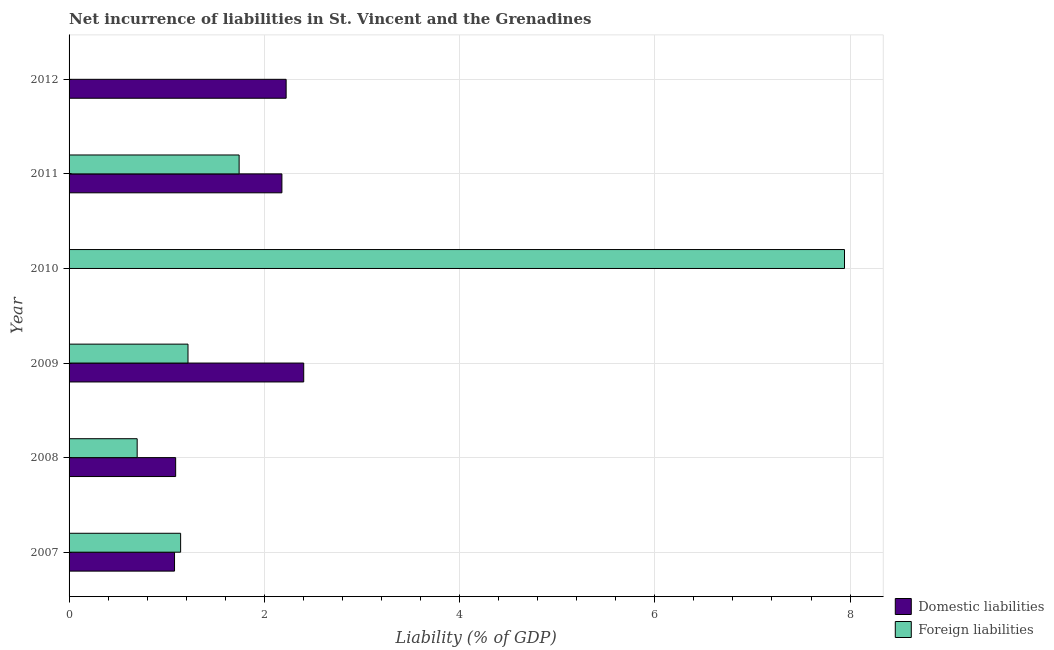Are the number of bars per tick equal to the number of legend labels?
Your answer should be compact. No. Are the number of bars on each tick of the Y-axis equal?
Offer a terse response. No. How many bars are there on the 1st tick from the top?
Provide a short and direct response. 1. In how many cases, is the number of bars for a given year not equal to the number of legend labels?
Your answer should be compact. 2. What is the incurrence of domestic liabilities in 2011?
Give a very brief answer. 2.18. Across all years, what is the maximum incurrence of domestic liabilities?
Provide a short and direct response. 2.4. In which year was the incurrence of domestic liabilities maximum?
Your answer should be very brief. 2009. What is the total incurrence of foreign liabilities in the graph?
Ensure brevity in your answer.  12.74. What is the difference between the incurrence of domestic liabilities in 2007 and that in 2009?
Offer a terse response. -1.32. What is the difference between the incurrence of domestic liabilities in 2008 and the incurrence of foreign liabilities in 2007?
Provide a short and direct response. -0.05. What is the average incurrence of foreign liabilities per year?
Give a very brief answer. 2.12. In the year 2007, what is the difference between the incurrence of domestic liabilities and incurrence of foreign liabilities?
Keep it short and to the point. -0.06. What is the ratio of the incurrence of foreign liabilities in 2007 to that in 2010?
Provide a succinct answer. 0.14. Is the incurrence of foreign liabilities in 2008 less than that in 2009?
Keep it short and to the point. Yes. Is the difference between the incurrence of domestic liabilities in 2007 and 2008 greater than the difference between the incurrence of foreign liabilities in 2007 and 2008?
Give a very brief answer. No. What is the difference between the highest and the second highest incurrence of foreign liabilities?
Your answer should be compact. 6.2. What is the difference between the highest and the lowest incurrence of foreign liabilities?
Ensure brevity in your answer.  7.94. Is the sum of the incurrence of domestic liabilities in 2008 and 2012 greater than the maximum incurrence of foreign liabilities across all years?
Offer a very short reply. No. How many bars are there?
Keep it short and to the point. 10. How many years are there in the graph?
Offer a very short reply. 6. Are the values on the major ticks of X-axis written in scientific E-notation?
Your response must be concise. No. Does the graph contain any zero values?
Give a very brief answer. Yes. Does the graph contain grids?
Offer a very short reply. Yes. How are the legend labels stacked?
Your answer should be compact. Vertical. What is the title of the graph?
Offer a terse response. Net incurrence of liabilities in St. Vincent and the Grenadines. What is the label or title of the X-axis?
Your answer should be very brief. Liability (% of GDP). What is the label or title of the Y-axis?
Provide a short and direct response. Year. What is the Liability (% of GDP) in Domestic liabilities in 2007?
Make the answer very short. 1.08. What is the Liability (% of GDP) of Foreign liabilities in 2007?
Give a very brief answer. 1.14. What is the Liability (% of GDP) of Domestic liabilities in 2008?
Your response must be concise. 1.09. What is the Liability (% of GDP) of Foreign liabilities in 2008?
Offer a terse response. 0.7. What is the Liability (% of GDP) in Domestic liabilities in 2009?
Provide a short and direct response. 2.4. What is the Liability (% of GDP) of Foreign liabilities in 2009?
Your answer should be very brief. 1.22. What is the Liability (% of GDP) of Foreign liabilities in 2010?
Your answer should be very brief. 7.94. What is the Liability (% of GDP) of Domestic liabilities in 2011?
Provide a succinct answer. 2.18. What is the Liability (% of GDP) of Foreign liabilities in 2011?
Your response must be concise. 1.74. What is the Liability (% of GDP) in Domestic liabilities in 2012?
Your answer should be compact. 2.22. Across all years, what is the maximum Liability (% of GDP) of Domestic liabilities?
Offer a very short reply. 2.4. Across all years, what is the maximum Liability (% of GDP) in Foreign liabilities?
Make the answer very short. 7.94. Across all years, what is the minimum Liability (% of GDP) in Foreign liabilities?
Offer a very short reply. 0. What is the total Liability (% of GDP) of Domestic liabilities in the graph?
Offer a very short reply. 8.98. What is the total Liability (% of GDP) in Foreign liabilities in the graph?
Keep it short and to the point. 12.74. What is the difference between the Liability (% of GDP) in Domestic liabilities in 2007 and that in 2008?
Offer a very short reply. -0.01. What is the difference between the Liability (% of GDP) in Foreign liabilities in 2007 and that in 2008?
Offer a terse response. 0.45. What is the difference between the Liability (% of GDP) in Domestic liabilities in 2007 and that in 2009?
Keep it short and to the point. -1.32. What is the difference between the Liability (% of GDP) of Foreign liabilities in 2007 and that in 2009?
Your answer should be very brief. -0.08. What is the difference between the Liability (% of GDP) of Foreign liabilities in 2007 and that in 2010?
Make the answer very short. -6.8. What is the difference between the Liability (% of GDP) in Domestic liabilities in 2007 and that in 2011?
Make the answer very short. -1.1. What is the difference between the Liability (% of GDP) in Foreign liabilities in 2007 and that in 2011?
Give a very brief answer. -0.6. What is the difference between the Liability (% of GDP) of Domestic liabilities in 2007 and that in 2012?
Your answer should be very brief. -1.14. What is the difference between the Liability (% of GDP) in Domestic liabilities in 2008 and that in 2009?
Offer a very short reply. -1.31. What is the difference between the Liability (% of GDP) of Foreign liabilities in 2008 and that in 2009?
Give a very brief answer. -0.52. What is the difference between the Liability (% of GDP) of Foreign liabilities in 2008 and that in 2010?
Your answer should be compact. -7.25. What is the difference between the Liability (% of GDP) in Domestic liabilities in 2008 and that in 2011?
Offer a terse response. -1.09. What is the difference between the Liability (% of GDP) of Foreign liabilities in 2008 and that in 2011?
Keep it short and to the point. -1.04. What is the difference between the Liability (% of GDP) in Domestic liabilities in 2008 and that in 2012?
Give a very brief answer. -1.13. What is the difference between the Liability (% of GDP) in Foreign liabilities in 2009 and that in 2010?
Ensure brevity in your answer.  -6.72. What is the difference between the Liability (% of GDP) in Domestic liabilities in 2009 and that in 2011?
Keep it short and to the point. 0.22. What is the difference between the Liability (% of GDP) in Foreign liabilities in 2009 and that in 2011?
Ensure brevity in your answer.  -0.52. What is the difference between the Liability (% of GDP) of Domestic liabilities in 2009 and that in 2012?
Your answer should be compact. 0.18. What is the difference between the Liability (% of GDP) of Foreign liabilities in 2010 and that in 2011?
Your answer should be very brief. 6.2. What is the difference between the Liability (% of GDP) in Domestic liabilities in 2011 and that in 2012?
Your answer should be compact. -0.04. What is the difference between the Liability (% of GDP) in Domestic liabilities in 2007 and the Liability (% of GDP) in Foreign liabilities in 2008?
Your answer should be compact. 0.38. What is the difference between the Liability (% of GDP) of Domestic liabilities in 2007 and the Liability (% of GDP) of Foreign liabilities in 2009?
Your answer should be compact. -0.14. What is the difference between the Liability (% of GDP) of Domestic liabilities in 2007 and the Liability (% of GDP) of Foreign liabilities in 2010?
Make the answer very short. -6.86. What is the difference between the Liability (% of GDP) in Domestic liabilities in 2007 and the Liability (% of GDP) in Foreign liabilities in 2011?
Keep it short and to the point. -0.66. What is the difference between the Liability (% of GDP) of Domestic liabilities in 2008 and the Liability (% of GDP) of Foreign liabilities in 2009?
Offer a very short reply. -0.13. What is the difference between the Liability (% of GDP) of Domestic liabilities in 2008 and the Liability (% of GDP) of Foreign liabilities in 2010?
Your answer should be compact. -6.85. What is the difference between the Liability (% of GDP) of Domestic liabilities in 2008 and the Liability (% of GDP) of Foreign liabilities in 2011?
Ensure brevity in your answer.  -0.65. What is the difference between the Liability (% of GDP) in Domestic liabilities in 2009 and the Liability (% of GDP) in Foreign liabilities in 2010?
Your answer should be very brief. -5.54. What is the difference between the Liability (% of GDP) in Domestic liabilities in 2009 and the Liability (% of GDP) in Foreign liabilities in 2011?
Ensure brevity in your answer.  0.66. What is the average Liability (% of GDP) of Domestic liabilities per year?
Provide a short and direct response. 1.5. What is the average Liability (% of GDP) in Foreign liabilities per year?
Make the answer very short. 2.12. In the year 2007, what is the difference between the Liability (% of GDP) in Domestic liabilities and Liability (% of GDP) in Foreign liabilities?
Make the answer very short. -0.06. In the year 2008, what is the difference between the Liability (% of GDP) in Domestic liabilities and Liability (% of GDP) in Foreign liabilities?
Your response must be concise. 0.39. In the year 2009, what is the difference between the Liability (% of GDP) in Domestic liabilities and Liability (% of GDP) in Foreign liabilities?
Offer a very short reply. 1.19. In the year 2011, what is the difference between the Liability (% of GDP) in Domestic liabilities and Liability (% of GDP) in Foreign liabilities?
Give a very brief answer. 0.44. What is the ratio of the Liability (% of GDP) of Foreign liabilities in 2007 to that in 2008?
Keep it short and to the point. 1.64. What is the ratio of the Liability (% of GDP) of Domestic liabilities in 2007 to that in 2009?
Your answer should be compact. 0.45. What is the ratio of the Liability (% of GDP) of Foreign liabilities in 2007 to that in 2009?
Offer a terse response. 0.94. What is the ratio of the Liability (% of GDP) of Foreign liabilities in 2007 to that in 2010?
Keep it short and to the point. 0.14. What is the ratio of the Liability (% of GDP) of Domestic liabilities in 2007 to that in 2011?
Your response must be concise. 0.5. What is the ratio of the Liability (% of GDP) in Foreign liabilities in 2007 to that in 2011?
Your response must be concise. 0.66. What is the ratio of the Liability (% of GDP) of Domestic liabilities in 2007 to that in 2012?
Provide a succinct answer. 0.49. What is the ratio of the Liability (% of GDP) in Domestic liabilities in 2008 to that in 2009?
Provide a short and direct response. 0.45. What is the ratio of the Liability (% of GDP) of Foreign liabilities in 2008 to that in 2009?
Ensure brevity in your answer.  0.57. What is the ratio of the Liability (% of GDP) in Foreign liabilities in 2008 to that in 2010?
Ensure brevity in your answer.  0.09. What is the ratio of the Liability (% of GDP) of Domestic liabilities in 2008 to that in 2011?
Your answer should be very brief. 0.5. What is the ratio of the Liability (% of GDP) of Foreign liabilities in 2008 to that in 2011?
Keep it short and to the point. 0.4. What is the ratio of the Liability (% of GDP) in Domestic liabilities in 2008 to that in 2012?
Your answer should be very brief. 0.49. What is the ratio of the Liability (% of GDP) in Foreign liabilities in 2009 to that in 2010?
Your answer should be compact. 0.15. What is the ratio of the Liability (% of GDP) in Domestic liabilities in 2009 to that in 2011?
Ensure brevity in your answer.  1.1. What is the ratio of the Liability (% of GDP) of Foreign liabilities in 2009 to that in 2011?
Your answer should be compact. 0.7. What is the ratio of the Liability (% of GDP) of Domestic liabilities in 2009 to that in 2012?
Keep it short and to the point. 1.08. What is the ratio of the Liability (% of GDP) of Foreign liabilities in 2010 to that in 2011?
Ensure brevity in your answer.  4.56. What is the ratio of the Liability (% of GDP) in Domestic liabilities in 2011 to that in 2012?
Your answer should be compact. 0.98. What is the difference between the highest and the second highest Liability (% of GDP) of Domestic liabilities?
Offer a terse response. 0.18. What is the difference between the highest and the second highest Liability (% of GDP) of Foreign liabilities?
Provide a short and direct response. 6.2. What is the difference between the highest and the lowest Liability (% of GDP) in Domestic liabilities?
Your answer should be very brief. 2.4. What is the difference between the highest and the lowest Liability (% of GDP) in Foreign liabilities?
Your response must be concise. 7.94. 